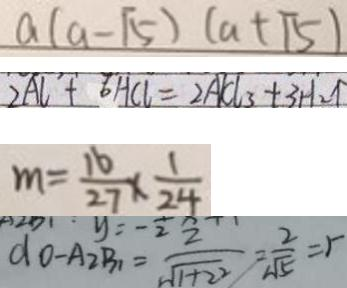<formula> <loc_0><loc_0><loc_500><loc_500>a ( a - \sqrt { 5 } ) ( a + \sqrt { 5 } ) 
 3 A L + 6 H C L = 2 A C _ { 3 } + 3 H _ { 2 } \uparrow 
 m = \frac { 1 6 } { 2 7 } \times \frac { 1 } { 2 4 } 
 d _ { 0 } - A _ { 2 } B _ { 1 } = \frac { 2 } { \sqrt { 1 + 2 ^ { 2 } } } = \frac { 2 } { \sqrt { 5 } } =</formula> 